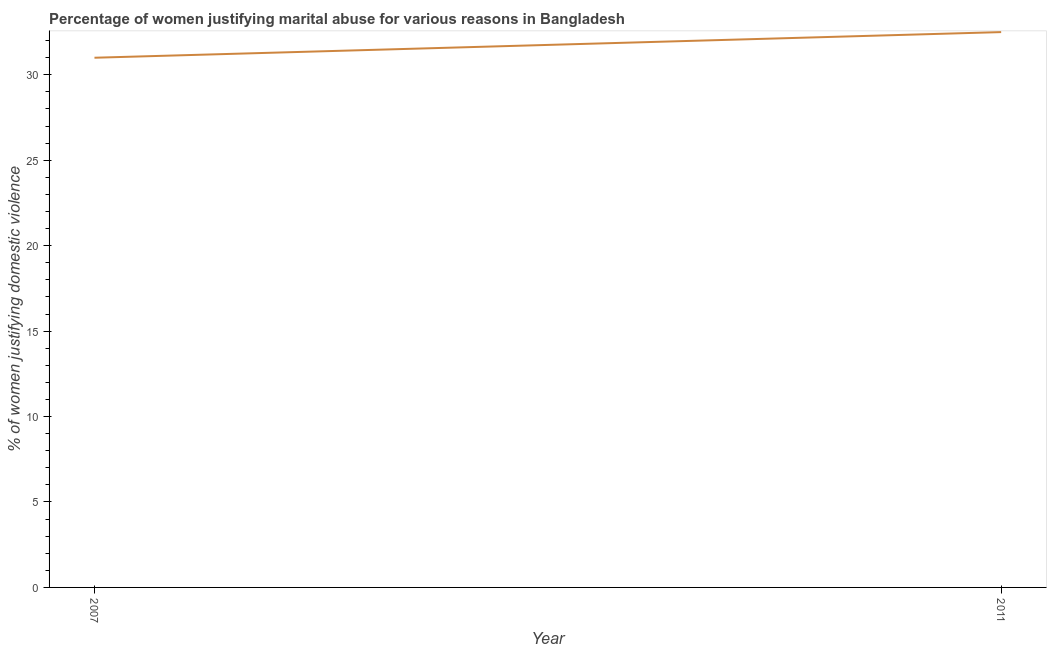Across all years, what is the maximum percentage of women justifying marital abuse?
Keep it short and to the point. 32.5. In which year was the percentage of women justifying marital abuse maximum?
Offer a terse response. 2011. What is the sum of the percentage of women justifying marital abuse?
Offer a very short reply. 63.5. What is the difference between the percentage of women justifying marital abuse in 2007 and 2011?
Give a very brief answer. -1.5. What is the average percentage of women justifying marital abuse per year?
Make the answer very short. 31.75. What is the median percentage of women justifying marital abuse?
Your answer should be compact. 31.75. In how many years, is the percentage of women justifying marital abuse greater than 8 %?
Offer a terse response. 2. Do a majority of the years between 2011 and 2007 (inclusive) have percentage of women justifying marital abuse greater than 18 %?
Offer a terse response. No. What is the ratio of the percentage of women justifying marital abuse in 2007 to that in 2011?
Keep it short and to the point. 0.95. Is the percentage of women justifying marital abuse in 2007 less than that in 2011?
Provide a succinct answer. Yes. Does the percentage of women justifying marital abuse monotonically increase over the years?
Make the answer very short. Yes. How many years are there in the graph?
Make the answer very short. 2. Are the values on the major ticks of Y-axis written in scientific E-notation?
Provide a succinct answer. No. Does the graph contain grids?
Offer a terse response. No. What is the title of the graph?
Give a very brief answer. Percentage of women justifying marital abuse for various reasons in Bangladesh. What is the label or title of the Y-axis?
Make the answer very short. % of women justifying domestic violence. What is the % of women justifying domestic violence in 2011?
Provide a succinct answer. 32.5. What is the ratio of the % of women justifying domestic violence in 2007 to that in 2011?
Keep it short and to the point. 0.95. 